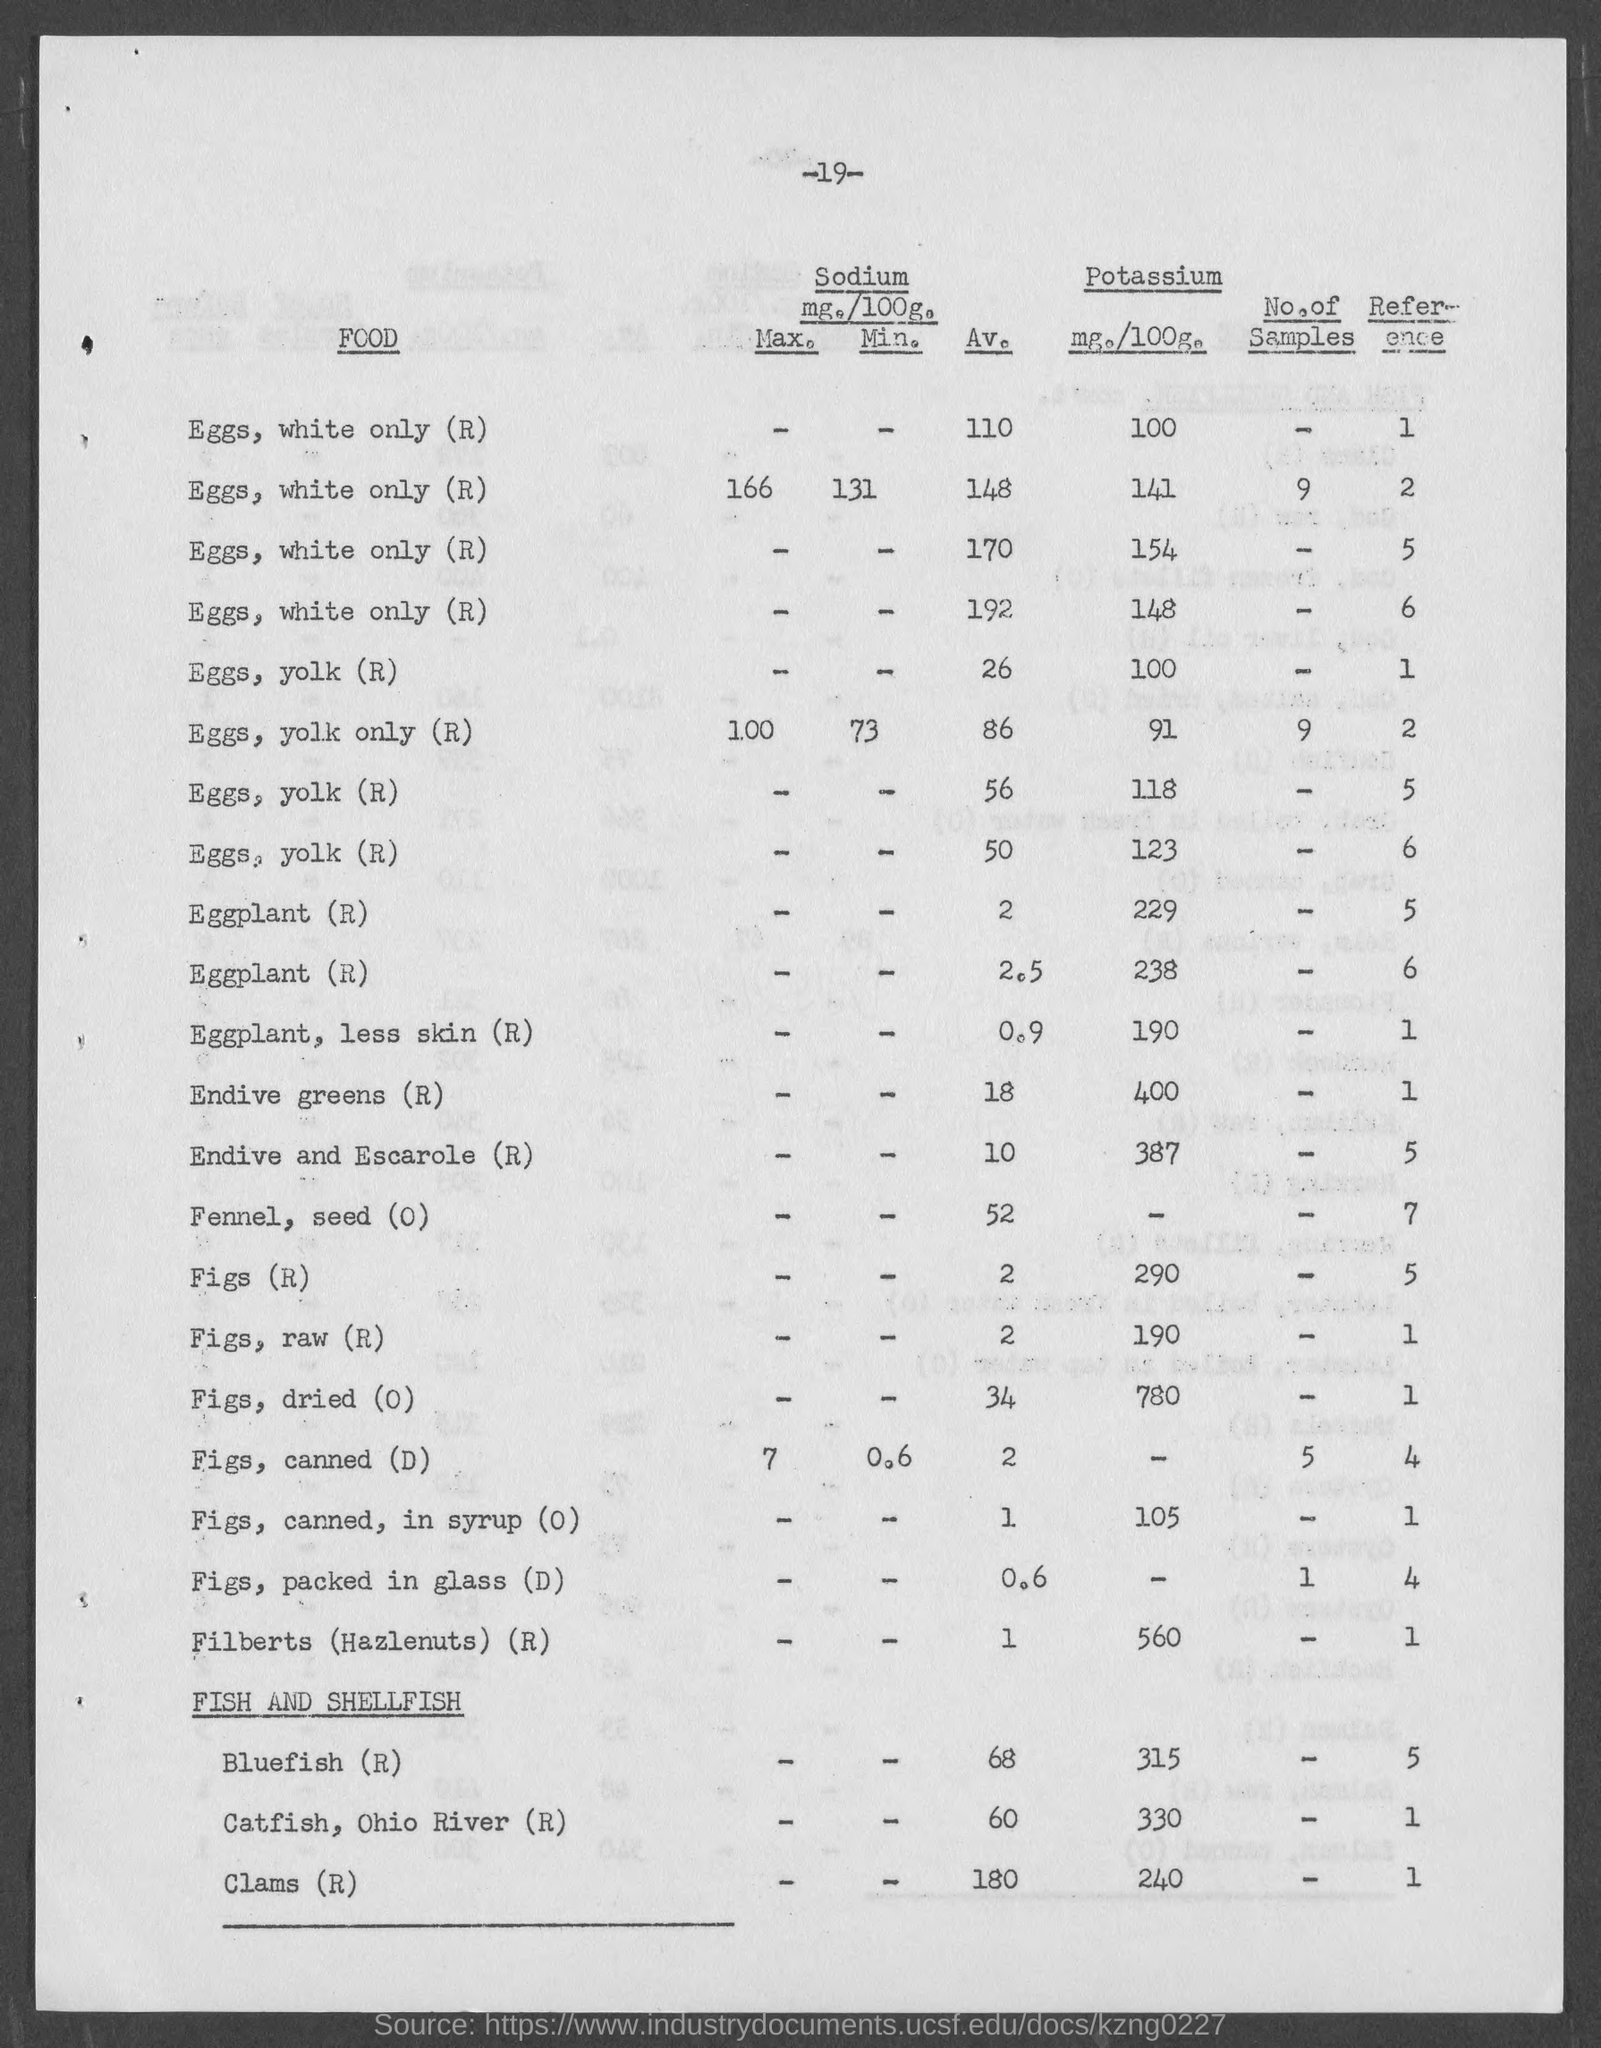Give some essential details in this illustration. The amount of potassium in canned figs in syrup is 105 milligrams per 100 grams. The amount of potassium in eggplant, without the skin (R), is 190 milligrams per 100 grams. The amount of potassium in 100 grams of Endive and Escarole (R) is 387 milligrams. The amount of potassium in figs, raw, is 190 milligrams per 100 grams. The amount of Potassium in 100 grams of dried figs (O) is 780 milligrams. 